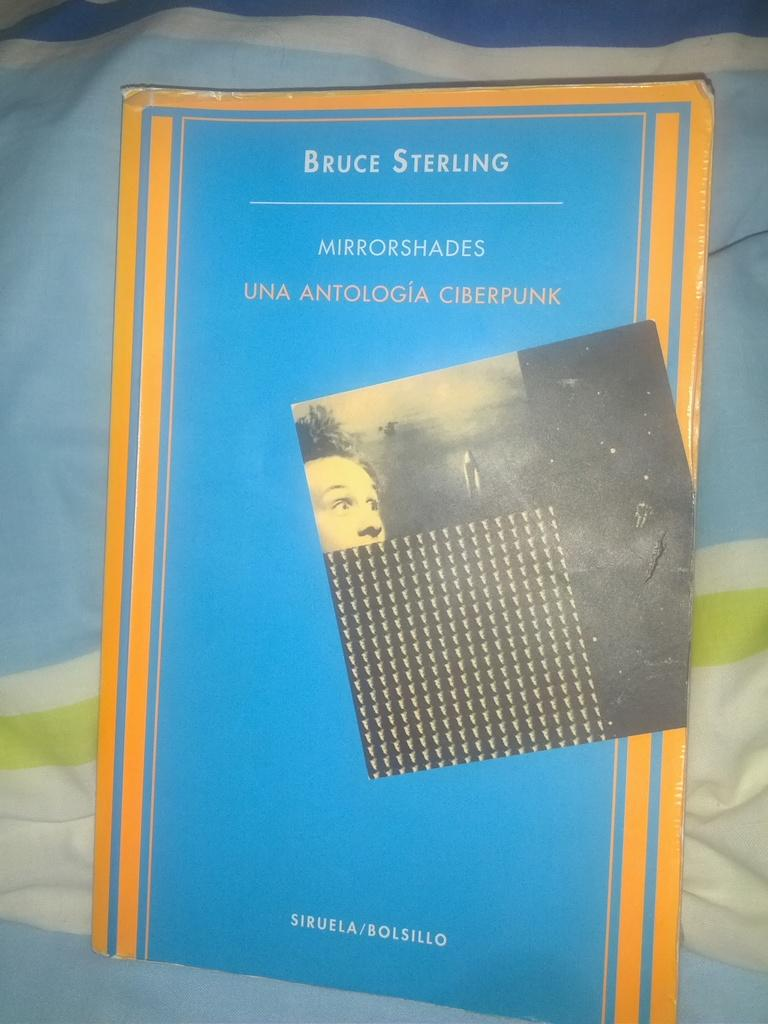<image>
Render a clear and concise summary of the photo. A book about mirror shades is on a piece of fabric. 